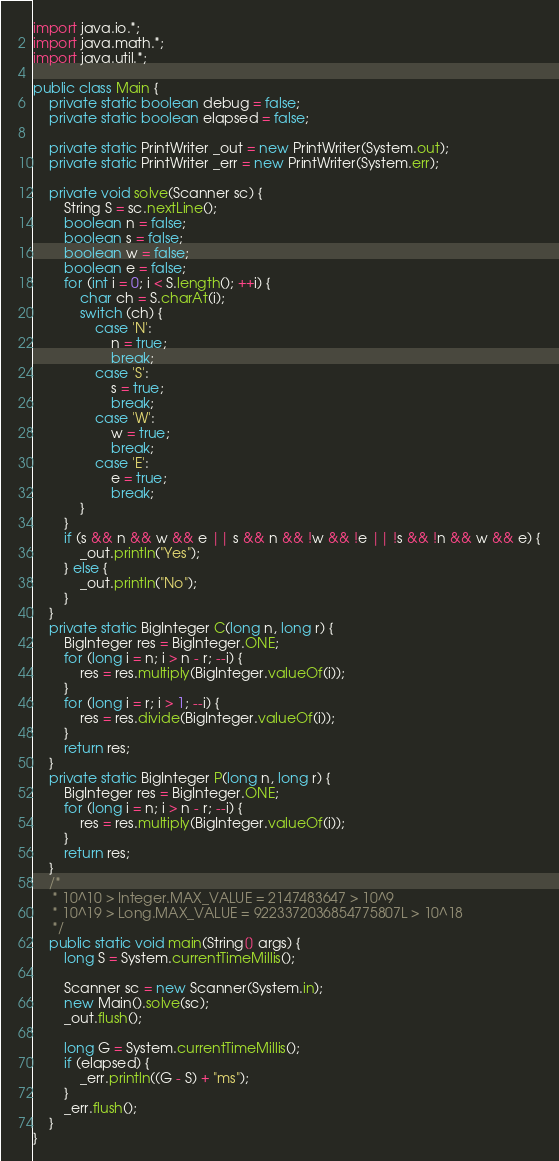<code> <loc_0><loc_0><loc_500><loc_500><_Java_>import java.io.*;
import java.math.*;
import java.util.*;

public class Main {
    private static boolean debug = false;
    private static boolean elapsed = false;

    private static PrintWriter _out = new PrintWriter(System.out);
    private static PrintWriter _err = new PrintWriter(System.err);

    private void solve(Scanner sc) {
        String S = sc.nextLine();
        boolean n = false;
        boolean s = false;
        boolean w = false;
        boolean e = false;
        for (int i = 0; i < S.length(); ++i) {
            char ch = S.charAt(i);
            switch (ch) {
                case 'N':
                    n = true;
                    break;
                case 'S':
                    s = true;
                    break;
                case 'W':
                    w = true;
                    break;
                case 'E':
                    e = true;
                    break;
            }
        }
        if (s && n && w && e || s && n && !w && !e || !s && !n && w && e) {
            _out.println("Yes");
        } else {
            _out.println("No");
        }
    }
    private static BigInteger C(long n, long r) {
        BigInteger res = BigInteger.ONE;
        for (long i = n; i > n - r; --i) {
            res = res.multiply(BigInteger.valueOf(i));
        }
        for (long i = r; i > 1; --i) {
            res = res.divide(BigInteger.valueOf(i));
        }
        return res;
    }
    private static BigInteger P(long n, long r) {
        BigInteger res = BigInteger.ONE;
        for (long i = n; i > n - r; --i) {
            res = res.multiply(BigInteger.valueOf(i));
        }
        return res;
    }
    /*
     * 10^10 > Integer.MAX_VALUE = 2147483647 > 10^9
     * 10^19 > Long.MAX_VALUE = 9223372036854775807L > 10^18
     */
    public static void main(String[] args) {
        long S = System.currentTimeMillis();

        Scanner sc = new Scanner(System.in);
        new Main().solve(sc);
        _out.flush();

        long G = System.currentTimeMillis();
        if (elapsed) {
            _err.println((G - S) + "ms");
        }
        _err.flush();
    }
}</code> 